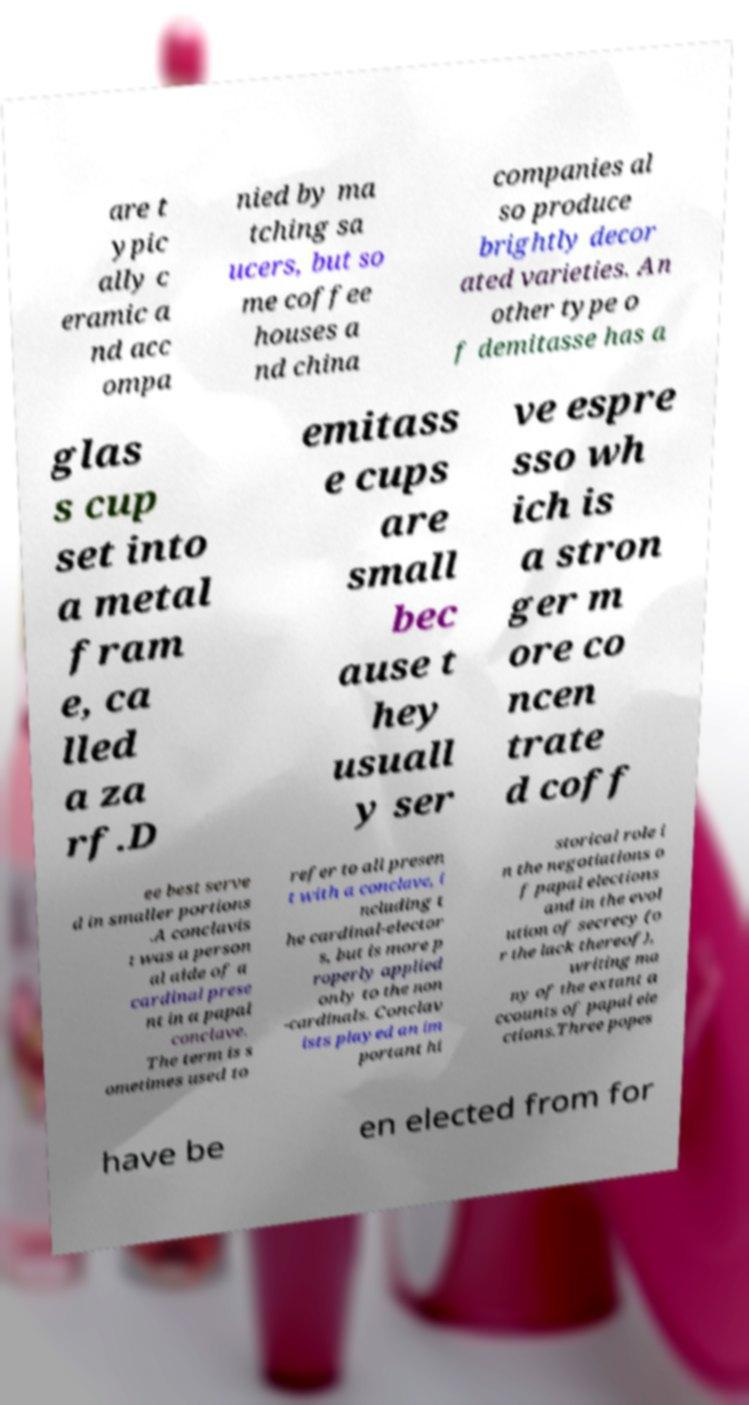Could you assist in decoding the text presented in this image and type it out clearly? are t ypic ally c eramic a nd acc ompa nied by ma tching sa ucers, but so me coffee houses a nd china companies al so produce brightly decor ated varieties. An other type o f demitasse has a glas s cup set into a metal fram e, ca lled a za rf.D emitass e cups are small bec ause t hey usuall y ser ve espre sso wh ich is a stron ger m ore co ncen trate d coff ee best serve d in smaller portions .A conclavis t was a person al aide of a cardinal prese nt in a papal conclave. The term is s ometimes used to refer to all presen t with a conclave, i ncluding t he cardinal-elector s, but is more p roperly applied only to the non -cardinals. Conclav ists played an im portant hi storical role i n the negotiations o f papal elections and in the evol ution of secrecy (o r the lack thereof), writing ma ny of the extant a ccounts of papal ele ctions.Three popes have be en elected from for 